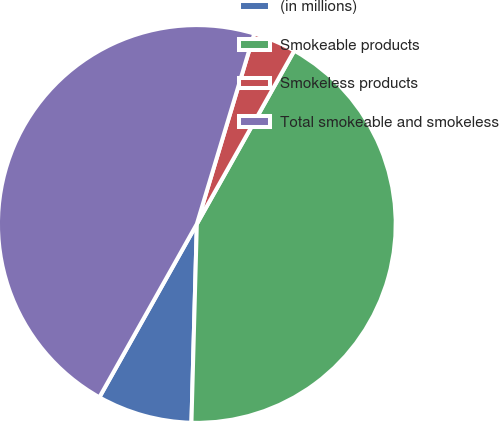Convert chart to OTSL. <chart><loc_0><loc_0><loc_500><loc_500><pie_chart><fcel>(in millions)<fcel>Smokeable products<fcel>Smokeless products<fcel>Total smokeable and smokeless<nl><fcel>7.72%<fcel>42.28%<fcel>3.49%<fcel>46.51%<nl></chart> 